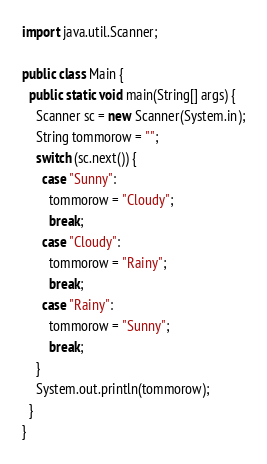Convert code to text. <code><loc_0><loc_0><loc_500><loc_500><_Java_>import java.util.Scanner;

public class Main {
  public static void main(String[] args) {
    Scanner sc = new Scanner(System.in);
    String tommorow = "";
    switch (sc.next()) {
      case "Sunny":
        tommorow = "Cloudy";
        break;
      case "Cloudy":
        tommorow = "Rainy";
        break;
      case "Rainy":
        tommorow = "Sunny";
        break;
    }
    System.out.println(tommorow);
  }
}</code> 